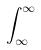<formula> <loc_0><loc_0><loc_500><loc_500>\int _ { \infty } ^ { \infty }</formula> 